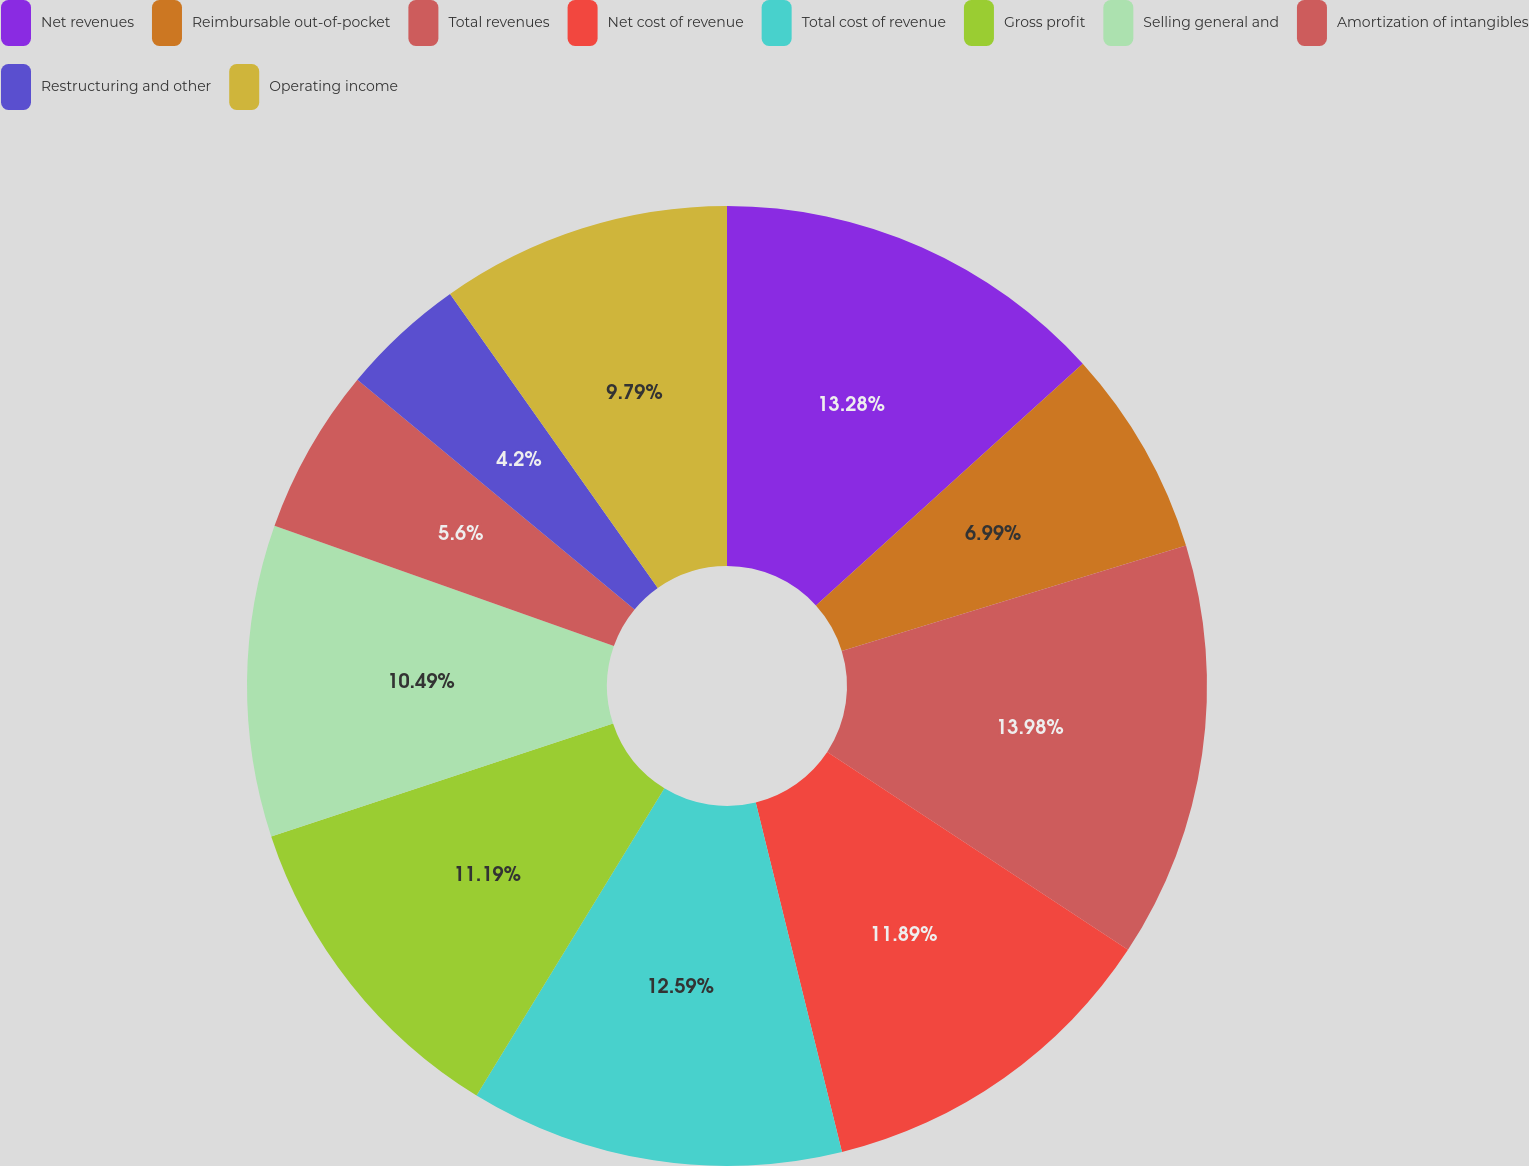Convert chart. <chart><loc_0><loc_0><loc_500><loc_500><pie_chart><fcel>Net revenues<fcel>Reimbursable out-of-pocket<fcel>Total revenues<fcel>Net cost of revenue<fcel>Total cost of revenue<fcel>Gross profit<fcel>Selling general and<fcel>Amortization of intangibles<fcel>Restructuring and other<fcel>Operating income<nl><fcel>13.29%<fcel>6.99%<fcel>13.99%<fcel>11.89%<fcel>12.59%<fcel>11.19%<fcel>10.49%<fcel>5.6%<fcel>4.2%<fcel>9.79%<nl></chart> 